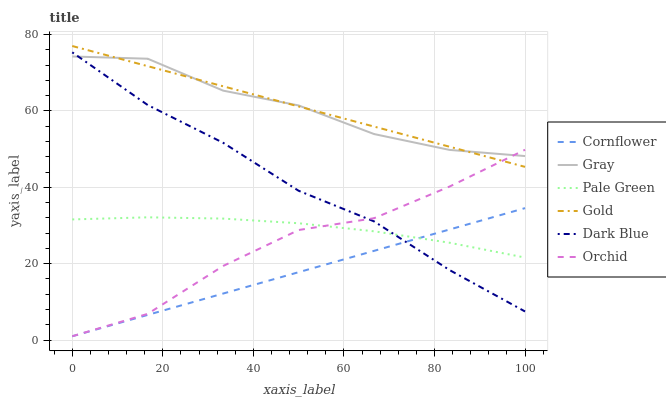Does Cornflower have the minimum area under the curve?
Answer yes or no. Yes. Does Gold have the maximum area under the curve?
Answer yes or no. Yes. Does Gray have the minimum area under the curve?
Answer yes or no. No. Does Gray have the maximum area under the curve?
Answer yes or no. No. Is Cornflower the smoothest?
Answer yes or no. Yes. Is Orchid the roughest?
Answer yes or no. Yes. Is Gold the smoothest?
Answer yes or no. No. Is Gold the roughest?
Answer yes or no. No. Does Cornflower have the lowest value?
Answer yes or no. Yes. Does Gold have the lowest value?
Answer yes or no. No. Does Gold have the highest value?
Answer yes or no. Yes. Does Gray have the highest value?
Answer yes or no. No. Is Dark Blue less than Gold?
Answer yes or no. Yes. Is Gold greater than Dark Blue?
Answer yes or no. Yes. Does Gray intersect Gold?
Answer yes or no. Yes. Is Gray less than Gold?
Answer yes or no. No. Is Gray greater than Gold?
Answer yes or no. No. Does Dark Blue intersect Gold?
Answer yes or no. No. 